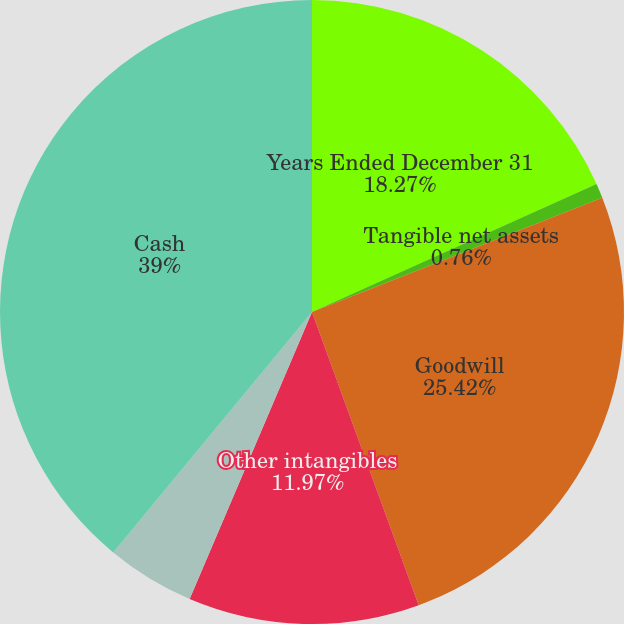Convert chart. <chart><loc_0><loc_0><loc_500><loc_500><pie_chart><fcel>Years Ended December 31<fcel>Tangible net assets<fcel>Goodwill<fcel>Other intangibles<fcel>In-process research and<fcel>Cash<nl><fcel>18.27%<fcel>0.76%<fcel>25.42%<fcel>11.97%<fcel>4.58%<fcel>39.01%<nl></chart> 